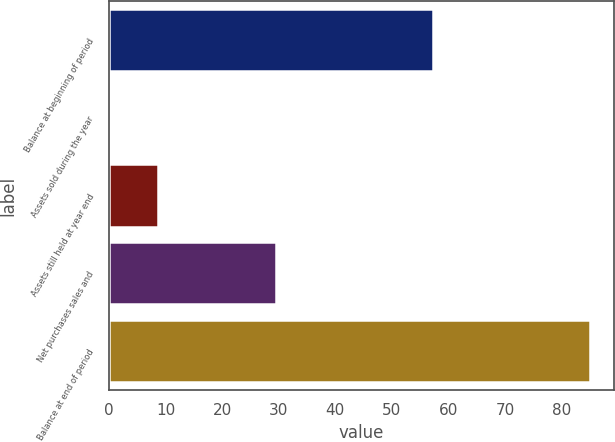<chart> <loc_0><loc_0><loc_500><loc_500><bar_chart><fcel>Balance at beginning of period<fcel>Assets sold during the year<fcel>Assets still held at year end<fcel>Net purchases sales and<fcel>Balance at end of period<nl><fcel>57.2<fcel>0.1<fcel>8.59<fcel>29.5<fcel>85<nl></chart> 